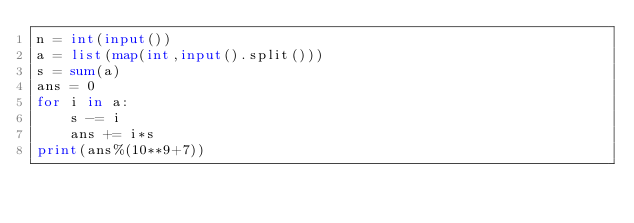<code> <loc_0><loc_0><loc_500><loc_500><_Python_>n = int(input())
a = list(map(int,input().split()))
s = sum(a)
ans = 0
for i in a:
    s -= i
    ans += i*s
print(ans%(10**9+7))</code> 